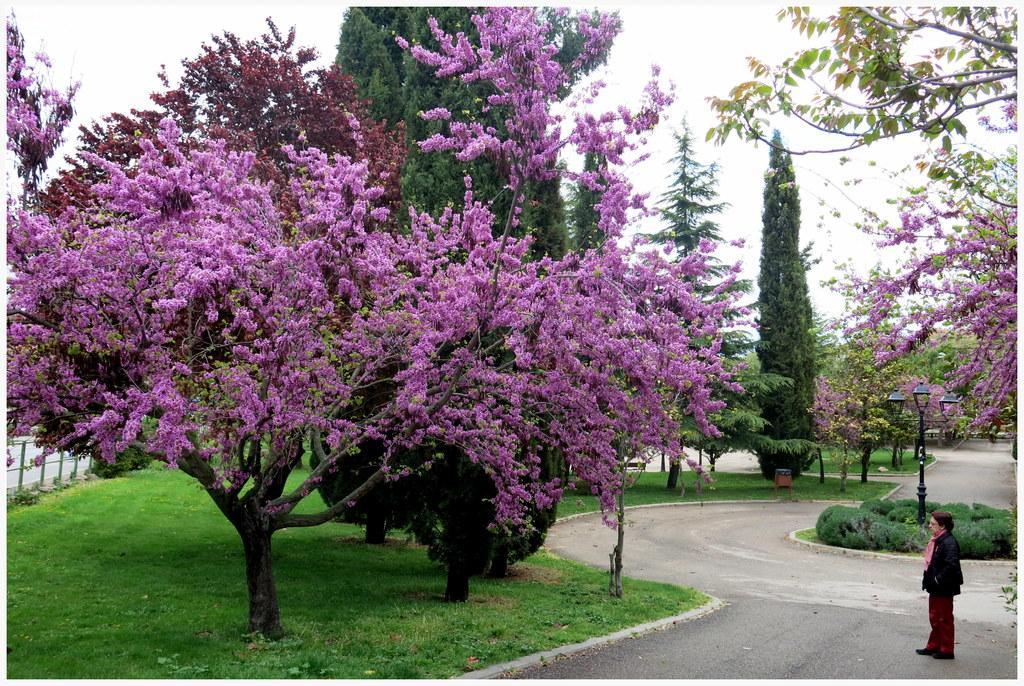How would you summarize this image in a sentence or two? On the right side, there is a person standing on the road. On the left side, there are trees, plants and grass on the ground. In the background, there are trees, plants, roads and grass on the ground and there are clouds in the sky. 